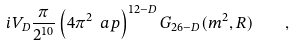Convert formula to latex. <formula><loc_0><loc_0><loc_500><loc_500>i V _ { D } \frac { \pi } { 2 ^ { 1 0 } } \left ( 4 \pi ^ { 2 } \ a p \right ) ^ { 1 2 - D } G _ { 2 6 - D } ( m ^ { 2 } , R ) \quad ,</formula> 